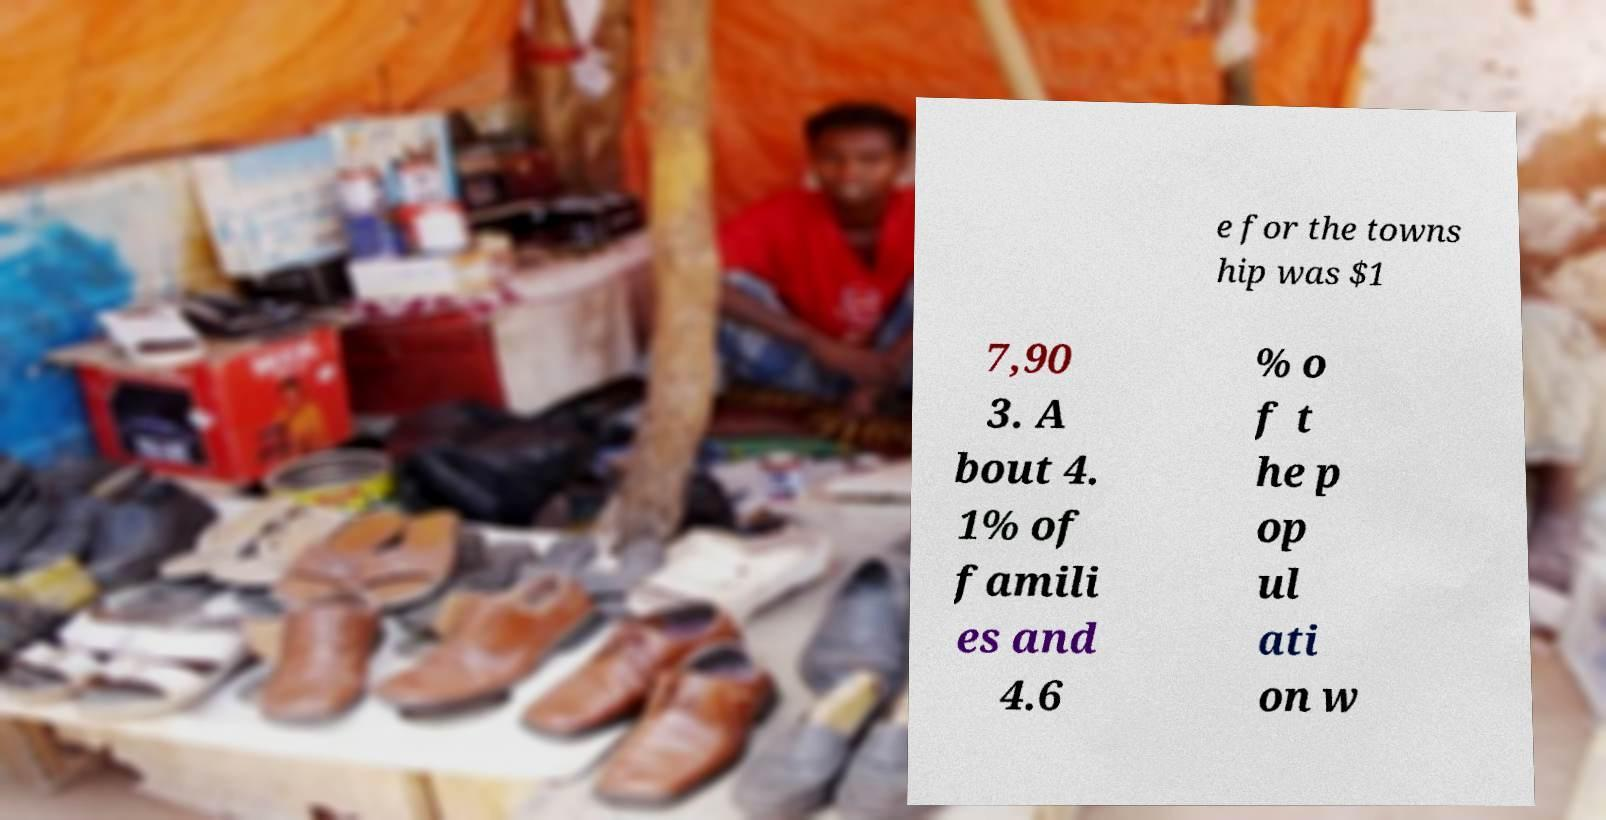Please identify and transcribe the text found in this image. e for the towns hip was $1 7,90 3. A bout 4. 1% of famili es and 4.6 % o f t he p op ul ati on w 